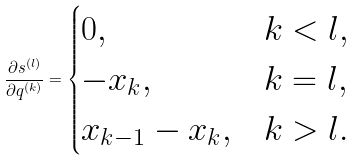<formula> <loc_0><loc_0><loc_500><loc_500>\frac { \partial s ^ { ( l ) } } { \partial q ^ { ( k ) } } = \begin{cases} 0 , & k < l , \\ - x _ { k } , & k = l , \\ x _ { k - 1 } - x _ { k } , & k > l . \end{cases}</formula> 